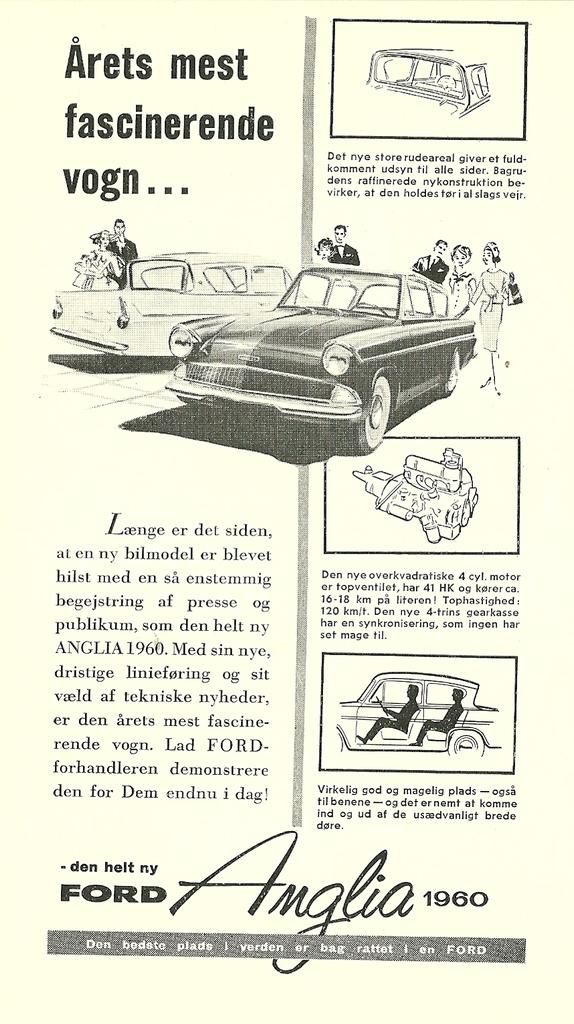What type of art is featured in the image? The image contains line art of car spare parts. Are there any other subjects or objects depicted in the image? Yes, there are depictions and drawings of people with cars in the image. Is there any text associated with the drawings and depictions? Yes, there is text associated with the drawings and depictions. What type of muscle can be seen flexing in the image? There is no muscle flexing or any human body parts present in the image; it features line art of car spare parts and drawings of people with cars. 